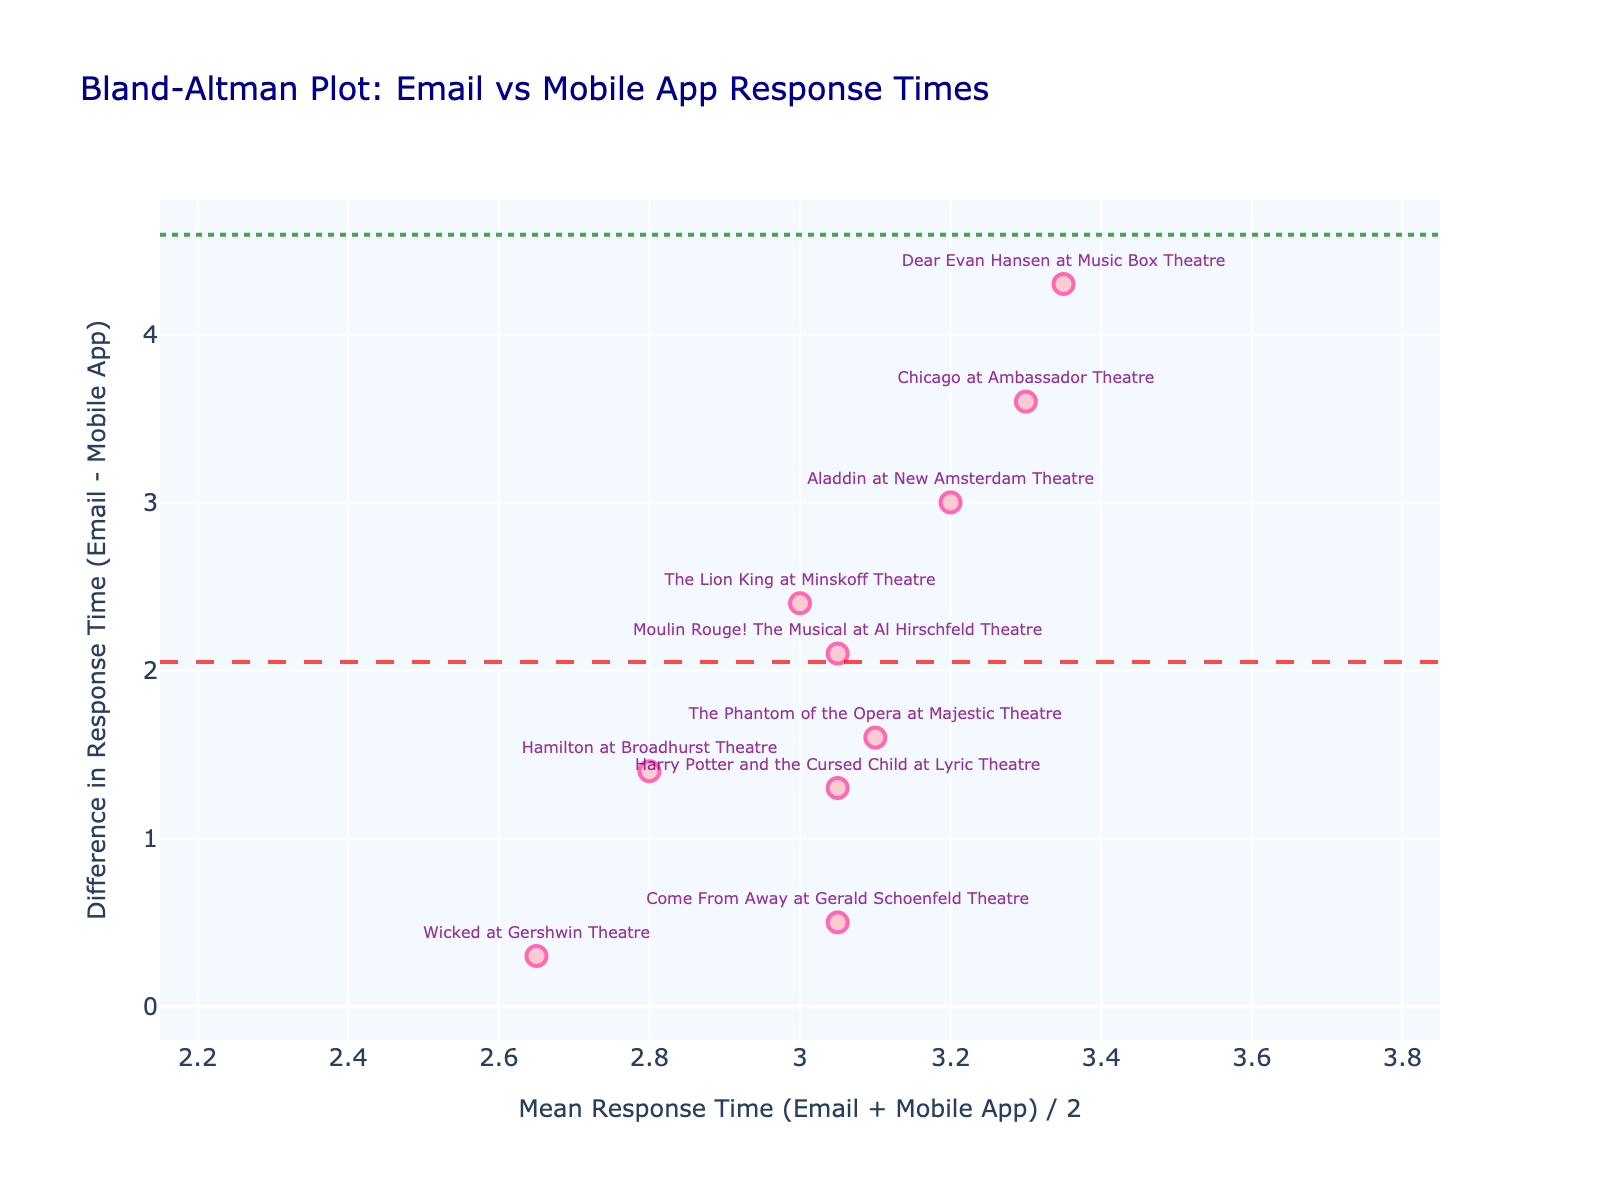What's the title of the plot? The title is usually prominently displayed at the top of the plot. Here, it says "Bland-Altman Plot: Email vs Mobile App Response Times".
Answer: Bland-Altman Plot: Email vs Mobile App Response Times How many data points are represented in the plot? Count the number of markers on the plot. Each marker corresponds to a data point.
Answer: 10 What are the mean difference and the limits of agreement indicated in the plot? Look at the horizontal lines on the plot. The dashed line is the mean difference, and the dotted lines are the limits of agreement. By examining the y-axis values, you can identify these key statistics.
Answer: Mean Difference ≈ 2.32, Limits of Agreement ≈ (-2.03, 6.67) Which theater event has the largest difference in response time between email and mobile app notifications? Identify the data point farthest from the mean difference line. The vertical position relative to the mean difference indicates the largest difference.
Answer: Dear Evan Hansen at Music Box Theatre Is there any event where the email response time was faster than the mobile app response time? Look for negative values on the y-axis, which represent email times being less than mobile app times. Here, finding points below the horizontal zero line indicates such cases.
Answer: No Which theater event has a mean response time closest to 4.0? Look along the x-axis for the value closest to 4.0 and check the associated data point to determine the corresponding theater event.
Answer: The Lion King at Minskoff Theatre Which theater event's response times show the smallest absolute difference between email and mobile app notifications? Identify the data point closest to the zero line (mean difference) on the y-axis, indicating the smallest difference.
Answer: Wicked at Gershwin Theatre How does the average response time of "Hamilton at Broadhurst Theatre" compare to "Moulin Rouge! The Musical at Al Hirschfeld Theatre"? Compare their x-axis (mean response time) positions. Determine which is larger or smaller by examining their horizontal positions.
Answer: Moulin Rouge! The Musical at Al Hirschfeld Theatre > Hamilton at Broadhurst Theatre For which theater events are the response times faster on mobile apps compared to email? Identify data points with positive values on the y-axis, indicating quicker response times on mobile apps compared to email. List the associated theaters.
Answer: All events (Hamilton, The Lion King, Wicked, Chicago, The Phantom of the Opera, Aladdin, Come From Away, Dear Evan Hansen, Moulin Rouge!, Harry Potter and the Cursed Child) What is the mean response time for "Chicago at Ambassador Theatre"? Sum the email and mobile app response times for this event and then divide by 2 to get the mean response time.
Answer: 3.3 